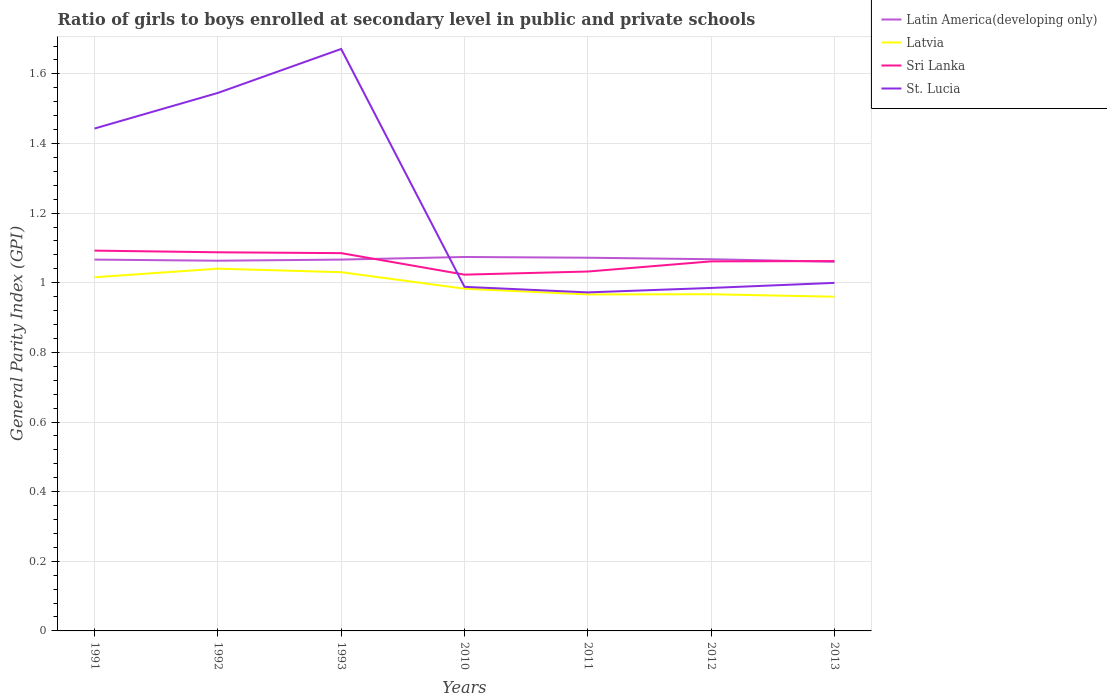Does the line corresponding to Latvia intersect with the line corresponding to St. Lucia?
Provide a short and direct response. No. Across all years, what is the maximum general parity index in Sri Lanka?
Provide a short and direct response. 1.02. In which year was the general parity index in Latvia maximum?
Provide a short and direct response. 2013. What is the total general parity index in Latvia in the graph?
Offer a terse response. 0.03. What is the difference between the highest and the second highest general parity index in Latvia?
Your response must be concise. 0.08. Is the general parity index in Latvia strictly greater than the general parity index in St. Lucia over the years?
Keep it short and to the point. Yes. How many years are there in the graph?
Offer a very short reply. 7. Are the values on the major ticks of Y-axis written in scientific E-notation?
Ensure brevity in your answer.  No. Does the graph contain any zero values?
Your response must be concise. No. Does the graph contain grids?
Ensure brevity in your answer.  Yes. How many legend labels are there?
Give a very brief answer. 4. How are the legend labels stacked?
Your answer should be compact. Vertical. What is the title of the graph?
Ensure brevity in your answer.  Ratio of girls to boys enrolled at secondary level in public and private schools. What is the label or title of the Y-axis?
Give a very brief answer. General Parity Index (GPI). What is the General Parity Index (GPI) of Latin America(developing only) in 1991?
Give a very brief answer. 1.07. What is the General Parity Index (GPI) in Latvia in 1991?
Your answer should be compact. 1.02. What is the General Parity Index (GPI) of Sri Lanka in 1991?
Your response must be concise. 1.09. What is the General Parity Index (GPI) of St. Lucia in 1991?
Your answer should be compact. 1.44. What is the General Parity Index (GPI) of Latin America(developing only) in 1992?
Make the answer very short. 1.06. What is the General Parity Index (GPI) of Latvia in 1992?
Provide a short and direct response. 1.04. What is the General Parity Index (GPI) of Sri Lanka in 1992?
Your response must be concise. 1.09. What is the General Parity Index (GPI) in St. Lucia in 1992?
Your response must be concise. 1.55. What is the General Parity Index (GPI) in Latin America(developing only) in 1993?
Offer a very short reply. 1.07. What is the General Parity Index (GPI) of Latvia in 1993?
Provide a succinct answer. 1.03. What is the General Parity Index (GPI) in Sri Lanka in 1993?
Give a very brief answer. 1.09. What is the General Parity Index (GPI) of St. Lucia in 1993?
Your answer should be compact. 1.67. What is the General Parity Index (GPI) of Latin America(developing only) in 2010?
Keep it short and to the point. 1.07. What is the General Parity Index (GPI) of Latvia in 2010?
Ensure brevity in your answer.  0.98. What is the General Parity Index (GPI) in Sri Lanka in 2010?
Your answer should be very brief. 1.02. What is the General Parity Index (GPI) in St. Lucia in 2010?
Make the answer very short. 0.99. What is the General Parity Index (GPI) of Latin America(developing only) in 2011?
Ensure brevity in your answer.  1.07. What is the General Parity Index (GPI) in Latvia in 2011?
Make the answer very short. 0.97. What is the General Parity Index (GPI) of Sri Lanka in 2011?
Make the answer very short. 1.03. What is the General Parity Index (GPI) in St. Lucia in 2011?
Provide a succinct answer. 0.97. What is the General Parity Index (GPI) in Latin America(developing only) in 2012?
Your answer should be compact. 1.07. What is the General Parity Index (GPI) in Latvia in 2012?
Provide a short and direct response. 0.97. What is the General Parity Index (GPI) in Sri Lanka in 2012?
Your answer should be very brief. 1.06. What is the General Parity Index (GPI) in St. Lucia in 2012?
Provide a short and direct response. 0.99. What is the General Parity Index (GPI) in Latin America(developing only) in 2013?
Offer a very short reply. 1.06. What is the General Parity Index (GPI) of Latvia in 2013?
Ensure brevity in your answer.  0.96. What is the General Parity Index (GPI) of Sri Lanka in 2013?
Ensure brevity in your answer.  1.06. What is the General Parity Index (GPI) in St. Lucia in 2013?
Make the answer very short. 1. Across all years, what is the maximum General Parity Index (GPI) of Latin America(developing only)?
Keep it short and to the point. 1.07. Across all years, what is the maximum General Parity Index (GPI) of Latvia?
Provide a short and direct response. 1.04. Across all years, what is the maximum General Parity Index (GPI) of Sri Lanka?
Make the answer very short. 1.09. Across all years, what is the maximum General Parity Index (GPI) of St. Lucia?
Make the answer very short. 1.67. Across all years, what is the minimum General Parity Index (GPI) of Latin America(developing only)?
Offer a very short reply. 1.06. Across all years, what is the minimum General Parity Index (GPI) of Latvia?
Ensure brevity in your answer.  0.96. Across all years, what is the minimum General Parity Index (GPI) of Sri Lanka?
Offer a terse response. 1.02. Across all years, what is the minimum General Parity Index (GPI) of St. Lucia?
Make the answer very short. 0.97. What is the total General Parity Index (GPI) in Latin America(developing only) in the graph?
Your response must be concise. 7.47. What is the total General Parity Index (GPI) of Latvia in the graph?
Offer a very short reply. 6.96. What is the total General Parity Index (GPI) in Sri Lanka in the graph?
Your answer should be very brief. 7.44. What is the total General Parity Index (GPI) of St. Lucia in the graph?
Offer a terse response. 8.61. What is the difference between the General Parity Index (GPI) in Latin America(developing only) in 1991 and that in 1992?
Keep it short and to the point. 0. What is the difference between the General Parity Index (GPI) in Latvia in 1991 and that in 1992?
Your answer should be very brief. -0.02. What is the difference between the General Parity Index (GPI) in Sri Lanka in 1991 and that in 1992?
Keep it short and to the point. 0. What is the difference between the General Parity Index (GPI) of St. Lucia in 1991 and that in 1992?
Provide a short and direct response. -0.1. What is the difference between the General Parity Index (GPI) in Latvia in 1991 and that in 1993?
Keep it short and to the point. -0.01. What is the difference between the General Parity Index (GPI) in Sri Lanka in 1991 and that in 1993?
Provide a short and direct response. 0.01. What is the difference between the General Parity Index (GPI) of St. Lucia in 1991 and that in 1993?
Provide a short and direct response. -0.23. What is the difference between the General Parity Index (GPI) in Latin America(developing only) in 1991 and that in 2010?
Your answer should be compact. -0.01. What is the difference between the General Parity Index (GPI) of Latvia in 1991 and that in 2010?
Your answer should be very brief. 0.03. What is the difference between the General Parity Index (GPI) of Sri Lanka in 1991 and that in 2010?
Offer a terse response. 0.07. What is the difference between the General Parity Index (GPI) in St. Lucia in 1991 and that in 2010?
Keep it short and to the point. 0.45. What is the difference between the General Parity Index (GPI) of Latin America(developing only) in 1991 and that in 2011?
Your answer should be compact. -0.01. What is the difference between the General Parity Index (GPI) of Latvia in 1991 and that in 2011?
Give a very brief answer. 0.05. What is the difference between the General Parity Index (GPI) in Sri Lanka in 1991 and that in 2011?
Offer a very short reply. 0.06. What is the difference between the General Parity Index (GPI) of St. Lucia in 1991 and that in 2011?
Provide a succinct answer. 0.47. What is the difference between the General Parity Index (GPI) in Latin America(developing only) in 1991 and that in 2012?
Offer a very short reply. -0. What is the difference between the General Parity Index (GPI) in Latvia in 1991 and that in 2012?
Your answer should be very brief. 0.05. What is the difference between the General Parity Index (GPI) in Sri Lanka in 1991 and that in 2012?
Give a very brief answer. 0.03. What is the difference between the General Parity Index (GPI) in St. Lucia in 1991 and that in 2012?
Provide a succinct answer. 0.46. What is the difference between the General Parity Index (GPI) in Latin America(developing only) in 1991 and that in 2013?
Ensure brevity in your answer.  0.01. What is the difference between the General Parity Index (GPI) in Latvia in 1991 and that in 2013?
Make the answer very short. 0.06. What is the difference between the General Parity Index (GPI) of St. Lucia in 1991 and that in 2013?
Your response must be concise. 0.44. What is the difference between the General Parity Index (GPI) in Latin America(developing only) in 1992 and that in 1993?
Give a very brief answer. -0. What is the difference between the General Parity Index (GPI) of Latvia in 1992 and that in 1993?
Keep it short and to the point. 0.01. What is the difference between the General Parity Index (GPI) in Sri Lanka in 1992 and that in 1993?
Keep it short and to the point. 0. What is the difference between the General Parity Index (GPI) of St. Lucia in 1992 and that in 1993?
Give a very brief answer. -0.13. What is the difference between the General Parity Index (GPI) in Latin America(developing only) in 1992 and that in 2010?
Make the answer very short. -0.01. What is the difference between the General Parity Index (GPI) of Latvia in 1992 and that in 2010?
Give a very brief answer. 0.06. What is the difference between the General Parity Index (GPI) of Sri Lanka in 1992 and that in 2010?
Offer a terse response. 0.06. What is the difference between the General Parity Index (GPI) of St. Lucia in 1992 and that in 2010?
Your answer should be compact. 0.56. What is the difference between the General Parity Index (GPI) in Latin America(developing only) in 1992 and that in 2011?
Your response must be concise. -0.01. What is the difference between the General Parity Index (GPI) in Latvia in 1992 and that in 2011?
Offer a terse response. 0.07. What is the difference between the General Parity Index (GPI) of Sri Lanka in 1992 and that in 2011?
Your response must be concise. 0.06. What is the difference between the General Parity Index (GPI) in St. Lucia in 1992 and that in 2011?
Your answer should be very brief. 0.57. What is the difference between the General Parity Index (GPI) of Latin America(developing only) in 1992 and that in 2012?
Offer a very short reply. -0. What is the difference between the General Parity Index (GPI) in Latvia in 1992 and that in 2012?
Keep it short and to the point. 0.07. What is the difference between the General Parity Index (GPI) in Sri Lanka in 1992 and that in 2012?
Make the answer very short. 0.03. What is the difference between the General Parity Index (GPI) in St. Lucia in 1992 and that in 2012?
Your response must be concise. 0.56. What is the difference between the General Parity Index (GPI) in Latin America(developing only) in 1992 and that in 2013?
Provide a succinct answer. 0. What is the difference between the General Parity Index (GPI) of Latvia in 1992 and that in 2013?
Keep it short and to the point. 0.08. What is the difference between the General Parity Index (GPI) in Sri Lanka in 1992 and that in 2013?
Give a very brief answer. 0.03. What is the difference between the General Parity Index (GPI) in St. Lucia in 1992 and that in 2013?
Make the answer very short. 0.55. What is the difference between the General Parity Index (GPI) of Latin America(developing only) in 1993 and that in 2010?
Keep it short and to the point. -0.01. What is the difference between the General Parity Index (GPI) of Latvia in 1993 and that in 2010?
Provide a short and direct response. 0.05. What is the difference between the General Parity Index (GPI) of Sri Lanka in 1993 and that in 2010?
Offer a very short reply. 0.06. What is the difference between the General Parity Index (GPI) of St. Lucia in 1993 and that in 2010?
Keep it short and to the point. 0.68. What is the difference between the General Parity Index (GPI) in Latin America(developing only) in 1993 and that in 2011?
Your answer should be very brief. -0.01. What is the difference between the General Parity Index (GPI) of Latvia in 1993 and that in 2011?
Give a very brief answer. 0.06. What is the difference between the General Parity Index (GPI) of Sri Lanka in 1993 and that in 2011?
Your response must be concise. 0.05. What is the difference between the General Parity Index (GPI) in St. Lucia in 1993 and that in 2011?
Make the answer very short. 0.7. What is the difference between the General Parity Index (GPI) in Latin America(developing only) in 1993 and that in 2012?
Provide a succinct answer. -0. What is the difference between the General Parity Index (GPI) of Latvia in 1993 and that in 2012?
Your response must be concise. 0.06. What is the difference between the General Parity Index (GPI) of Sri Lanka in 1993 and that in 2012?
Your response must be concise. 0.02. What is the difference between the General Parity Index (GPI) of St. Lucia in 1993 and that in 2012?
Your response must be concise. 0.69. What is the difference between the General Parity Index (GPI) of Latin America(developing only) in 1993 and that in 2013?
Offer a terse response. 0.01. What is the difference between the General Parity Index (GPI) of Latvia in 1993 and that in 2013?
Offer a terse response. 0.07. What is the difference between the General Parity Index (GPI) of Sri Lanka in 1993 and that in 2013?
Offer a very short reply. 0.02. What is the difference between the General Parity Index (GPI) of St. Lucia in 1993 and that in 2013?
Provide a succinct answer. 0.67. What is the difference between the General Parity Index (GPI) of Latin America(developing only) in 2010 and that in 2011?
Provide a succinct answer. 0. What is the difference between the General Parity Index (GPI) of Latvia in 2010 and that in 2011?
Make the answer very short. 0.02. What is the difference between the General Parity Index (GPI) in Sri Lanka in 2010 and that in 2011?
Ensure brevity in your answer.  -0.01. What is the difference between the General Parity Index (GPI) of St. Lucia in 2010 and that in 2011?
Your answer should be compact. 0.02. What is the difference between the General Parity Index (GPI) of Latin America(developing only) in 2010 and that in 2012?
Give a very brief answer. 0.01. What is the difference between the General Parity Index (GPI) of Latvia in 2010 and that in 2012?
Your answer should be compact. 0.02. What is the difference between the General Parity Index (GPI) of Sri Lanka in 2010 and that in 2012?
Offer a very short reply. -0.04. What is the difference between the General Parity Index (GPI) of St. Lucia in 2010 and that in 2012?
Ensure brevity in your answer.  0. What is the difference between the General Parity Index (GPI) in Latin America(developing only) in 2010 and that in 2013?
Your response must be concise. 0.01. What is the difference between the General Parity Index (GPI) in Latvia in 2010 and that in 2013?
Offer a terse response. 0.02. What is the difference between the General Parity Index (GPI) of Sri Lanka in 2010 and that in 2013?
Your answer should be very brief. -0.04. What is the difference between the General Parity Index (GPI) of St. Lucia in 2010 and that in 2013?
Make the answer very short. -0.01. What is the difference between the General Parity Index (GPI) of Latin America(developing only) in 2011 and that in 2012?
Offer a very short reply. 0. What is the difference between the General Parity Index (GPI) in Latvia in 2011 and that in 2012?
Make the answer very short. -0. What is the difference between the General Parity Index (GPI) in Sri Lanka in 2011 and that in 2012?
Ensure brevity in your answer.  -0.03. What is the difference between the General Parity Index (GPI) of St. Lucia in 2011 and that in 2012?
Ensure brevity in your answer.  -0.01. What is the difference between the General Parity Index (GPI) of Latin America(developing only) in 2011 and that in 2013?
Give a very brief answer. 0.01. What is the difference between the General Parity Index (GPI) in Latvia in 2011 and that in 2013?
Make the answer very short. 0.01. What is the difference between the General Parity Index (GPI) of Sri Lanka in 2011 and that in 2013?
Make the answer very short. -0.03. What is the difference between the General Parity Index (GPI) of St. Lucia in 2011 and that in 2013?
Offer a terse response. -0.03. What is the difference between the General Parity Index (GPI) in Latin America(developing only) in 2012 and that in 2013?
Offer a very short reply. 0.01. What is the difference between the General Parity Index (GPI) of Latvia in 2012 and that in 2013?
Provide a short and direct response. 0.01. What is the difference between the General Parity Index (GPI) of Sri Lanka in 2012 and that in 2013?
Ensure brevity in your answer.  -0. What is the difference between the General Parity Index (GPI) of St. Lucia in 2012 and that in 2013?
Ensure brevity in your answer.  -0.01. What is the difference between the General Parity Index (GPI) of Latin America(developing only) in 1991 and the General Parity Index (GPI) of Latvia in 1992?
Give a very brief answer. 0.03. What is the difference between the General Parity Index (GPI) in Latin America(developing only) in 1991 and the General Parity Index (GPI) in Sri Lanka in 1992?
Keep it short and to the point. -0.02. What is the difference between the General Parity Index (GPI) of Latin America(developing only) in 1991 and the General Parity Index (GPI) of St. Lucia in 1992?
Make the answer very short. -0.48. What is the difference between the General Parity Index (GPI) in Latvia in 1991 and the General Parity Index (GPI) in Sri Lanka in 1992?
Keep it short and to the point. -0.07. What is the difference between the General Parity Index (GPI) in Latvia in 1991 and the General Parity Index (GPI) in St. Lucia in 1992?
Ensure brevity in your answer.  -0.53. What is the difference between the General Parity Index (GPI) of Sri Lanka in 1991 and the General Parity Index (GPI) of St. Lucia in 1992?
Provide a short and direct response. -0.45. What is the difference between the General Parity Index (GPI) of Latin America(developing only) in 1991 and the General Parity Index (GPI) of Latvia in 1993?
Your answer should be very brief. 0.04. What is the difference between the General Parity Index (GPI) in Latin America(developing only) in 1991 and the General Parity Index (GPI) in Sri Lanka in 1993?
Provide a short and direct response. -0.02. What is the difference between the General Parity Index (GPI) in Latin America(developing only) in 1991 and the General Parity Index (GPI) in St. Lucia in 1993?
Your response must be concise. -0.6. What is the difference between the General Parity Index (GPI) of Latvia in 1991 and the General Parity Index (GPI) of Sri Lanka in 1993?
Your answer should be very brief. -0.07. What is the difference between the General Parity Index (GPI) in Latvia in 1991 and the General Parity Index (GPI) in St. Lucia in 1993?
Your answer should be very brief. -0.66. What is the difference between the General Parity Index (GPI) in Sri Lanka in 1991 and the General Parity Index (GPI) in St. Lucia in 1993?
Make the answer very short. -0.58. What is the difference between the General Parity Index (GPI) of Latin America(developing only) in 1991 and the General Parity Index (GPI) of Latvia in 2010?
Make the answer very short. 0.08. What is the difference between the General Parity Index (GPI) of Latin America(developing only) in 1991 and the General Parity Index (GPI) of Sri Lanka in 2010?
Your response must be concise. 0.04. What is the difference between the General Parity Index (GPI) of Latin America(developing only) in 1991 and the General Parity Index (GPI) of St. Lucia in 2010?
Your answer should be very brief. 0.08. What is the difference between the General Parity Index (GPI) of Latvia in 1991 and the General Parity Index (GPI) of Sri Lanka in 2010?
Offer a terse response. -0.01. What is the difference between the General Parity Index (GPI) of Latvia in 1991 and the General Parity Index (GPI) of St. Lucia in 2010?
Keep it short and to the point. 0.03. What is the difference between the General Parity Index (GPI) in Sri Lanka in 1991 and the General Parity Index (GPI) in St. Lucia in 2010?
Your answer should be very brief. 0.1. What is the difference between the General Parity Index (GPI) in Latin America(developing only) in 1991 and the General Parity Index (GPI) in Latvia in 2011?
Your answer should be compact. 0.1. What is the difference between the General Parity Index (GPI) of Latin America(developing only) in 1991 and the General Parity Index (GPI) of Sri Lanka in 2011?
Your answer should be very brief. 0.03. What is the difference between the General Parity Index (GPI) in Latin America(developing only) in 1991 and the General Parity Index (GPI) in St. Lucia in 2011?
Your answer should be very brief. 0.09. What is the difference between the General Parity Index (GPI) in Latvia in 1991 and the General Parity Index (GPI) in Sri Lanka in 2011?
Offer a very short reply. -0.02. What is the difference between the General Parity Index (GPI) in Latvia in 1991 and the General Parity Index (GPI) in St. Lucia in 2011?
Offer a terse response. 0.04. What is the difference between the General Parity Index (GPI) of Sri Lanka in 1991 and the General Parity Index (GPI) of St. Lucia in 2011?
Provide a succinct answer. 0.12. What is the difference between the General Parity Index (GPI) of Latin America(developing only) in 1991 and the General Parity Index (GPI) of Latvia in 2012?
Provide a succinct answer. 0.1. What is the difference between the General Parity Index (GPI) in Latin America(developing only) in 1991 and the General Parity Index (GPI) in Sri Lanka in 2012?
Provide a short and direct response. 0.01. What is the difference between the General Parity Index (GPI) in Latin America(developing only) in 1991 and the General Parity Index (GPI) in St. Lucia in 2012?
Your answer should be compact. 0.08. What is the difference between the General Parity Index (GPI) in Latvia in 1991 and the General Parity Index (GPI) in Sri Lanka in 2012?
Give a very brief answer. -0.05. What is the difference between the General Parity Index (GPI) of Latvia in 1991 and the General Parity Index (GPI) of St. Lucia in 2012?
Offer a terse response. 0.03. What is the difference between the General Parity Index (GPI) of Sri Lanka in 1991 and the General Parity Index (GPI) of St. Lucia in 2012?
Give a very brief answer. 0.11. What is the difference between the General Parity Index (GPI) of Latin America(developing only) in 1991 and the General Parity Index (GPI) of Latvia in 2013?
Offer a very short reply. 0.11. What is the difference between the General Parity Index (GPI) in Latin America(developing only) in 1991 and the General Parity Index (GPI) in Sri Lanka in 2013?
Offer a very short reply. 0. What is the difference between the General Parity Index (GPI) in Latin America(developing only) in 1991 and the General Parity Index (GPI) in St. Lucia in 2013?
Your answer should be compact. 0.07. What is the difference between the General Parity Index (GPI) in Latvia in 1991 and the General Parity Index (GPI) in Sri Lanka in 2013?
Give a very brief answer. -0.05. What is the difference between the General Parity Index (GPI) of Latvia in 1991 and the General Parity Index (GPI) of St. Lucia in 2013?
Your response must be concise. 0.02. What is the difference between the General Parity Index (GPI) of Sri Lanka in 1991 and the General Parity Index (GPI) of St. Lucia in 2013?
Ensure brevity in your answer.  0.09. What is the difference between the General Parity Index (GPI) of Latin America(developing only) in 1992 and the General Parity Index (GPI) of Latvia in 1993?
Ensure brevity in your answer.  0.03. What is the difference between the General Parity Index (GPI) in Latin America(developing only) in 1992 and the General Parity Index (GPI) in Sri Lanka in 1993?
Keep it short and to the point. -0.02. What is the difference between the General Parity Index (GPI) of Latin America(developing only) in 1992 and the General Parity Index (GPI) of St. Lucia in 1993?
Offer a terse response. -0.61. What is the difference between the General Parity Index (GPI) of Latvia in 1992 and the General Parity Index (GPI) of Sri Lanka in 1993?
Make the answer very short. -0.04. What is the difference between the General Parity Index (GPI) of Latvia in 1992 and the General Parity Index (GPI) of St. Lucia in 1993?
Your response must be concise. -0.63. What is the difference between the General Parity Index (GPI) of Sri Lanka in 1992 and the General Parity Index (GPI) of St. Lucia in 1993?
Provide a short and direct response. -0.58. What is the difference between the General Parity Index (GPI) of Latin America(developing only) in 1992 and the General Parity Index (GPI) of Latvia in 2010?
Your answer should be compact. 0.08. What is the difference between the General Parity Index (GPI) in Latin America(developing only) in 1992 and the General Parity Index (GPI) in Sri Lanka in 2010?
Make the answer very short. 0.04. What is the difference between the General Parity Index (GPI) of Latin America(developing only) in 1992 and the General Parity Index (GPI) of St. Lucia in 2010?
Provide a succinct answer. 0.07. What is the difference between the General Parity Index (GPI) in Latvia in 1992 and the General Parity Index (GPI) in Sri Lanka in 2010?
Provide a short and direct response. 0.02. What is the difference between the General Parity Index (GPI) of Latvia in 1992 and the General Parity Index (GPI) of St. Lucia in 2010?
Give a very brief answer. 0.05. What is the difference between the General Parity Index (GPI) in Sri Lanka in 1992 and the General Parity Index (GPI) in St. Lucia in 2010?
Give a very brief answer. 0.1. What is the difference between the General Parity Index (GPI) in Latin America(developing only) in 1992 and the General Parity Index (GPI) in Latvia in 2011?
Keep it short and to the point. 0.1. What is the difference between the General Parity Index (GPI) in Latin America(developing only) in 1992 and the General Parity Index (GPI) in Sri Lanka in 2011?
Your answer should be very brief. 0.03. What is the difference between the General Parity Index (GPI) of Latin America(developing only) in 1992 and the General Parity Index (GPI) of St. Lucia in 2011?
Offer a terse response. 0.09. What is the difference between the General Parity Index (GPI) in Latvia in 1992 and the General Parity Index (GPI) in Sri Lanka in 2011?
Provide a short and direct response. 0.01. What is the difference between the General Parity Index (GPI) of Latvia in 1992 and the General Parity Index (GPI) of St. Lucia in 2011?
Ensure brevity in your answer.  0.07. What is the difference between the General Parity Index (GPI) in Sri Lanka in 1992 and the General Parity Index (GPI) in St. Lucia in 2011?
Provide a short and direct response. 0.12. What is the difference between the General Parity Index (GPI) of Latin America(developing only) in 1992 and the General Parity Index (GPI) of Latvia in 2012?
Your answer should be very brief. 0.1. What is the difference between the General Parity Index (GPI) of Latin America(developing only) in 1992 and the General Parity Index (GPI) of Sri Lanka in 2012?
Your answer should be very brief. 0. What is the difference between the General Parity Index (GPI) of Latin America(developing only) in 1992 and the General Parity Index (GPI) of St. Lucia in 2012?
Your answer should be compact. 0.08. What is the difference between the General Parity Index (GPI) of Latvia in 1992 and the General Parity Index (GPI) of Sri Lanka in 2012?
Give a very brief answer. -0.02. What is the difference between the General Parity Index (GPI) in Latvia in 1992 and the General Parity Index (GPI) in St. Lucia in 2012?
Offer a very short reply. 0.06. What is the difference between the General Parity Index (GPI) of Sri Lanka in 1992 and the General Parity Index (GPI) of St. Lucia in 2012?
Provide a succinct answer. 0.1. What is the difference between the General Parity Index (GPI) in Latin America(developing only) in 1992 and the General Parity Index (GPI) in Latvia in 2013?
Offer a very short reply. 0.1. What is the difference between the General Parity Index (GPI) of Latin America(developing only) in 1992 and the General Parity Index (GPI) of St. Lucia in 2013?
Your answer should be compact. 0.06. What is the difference between the General Parity Index (GPI) in Latvia in 1992 and the General Parity Index (GPI) in Sri Lanka in 2013?
Make the answer very short. -0.02. What is the difference between the General Parity Index (GPI) in Latvia in 1992 and the General Parity Index (GPI) in St. Lucia in 2013?
Make the answer very short. 0.04. What is the difference between the General Parity Index (GPI) in Sri Lanka in 1992 and the General Parity Index (GPI) in St. Lucia in 2013?
Your answer should be compact. 0.09. What is the difference between the General Parity Index (GPI) in Latin America(developing only) in 1993 and the General Parity Index (GPI) in Latvia in 2010?
Your response must be concise. 0.08. What is the difference between the General Parity Index (GPI) of Latin America(developing only) in 1993 and the General Parity Index (GPI) of Sri Lanka in 2010?
Provide a short and direct response. 0.04. What is the difference between the General Parity Index (GPI) in Latin America(developing only) in 1993 and the General Parity Index (GPI) in St. Lucia in 2010?
Your response must be concise. 0.08. What is the difference between the General Parity Index (GPI) in Latvia in 1993 and the General Parity Index (GPI) in Sri Lanka in 2010?
Make the answer very short. 0.01. What is the difference between the General Parity Index (GPI) in Latvia in 1993 and the General Parity Index (GPI) in St. Lucia in 2010?
Keep it short and to the point. 0.04. What is the difference between the General Parity Index (GPI) of Sri Lanka in 1993 and the General Parity Index (GPI) of St. Lucia in 2010?
Provide a succinct answer. 0.1. What is the difference between the General Parity Index (GPI) in Latin America(developing only) in 1993 and the General Parity Index (GPI) in Latvia in 2011?
Your response must be concise. 0.1. What is the difference between the General Parity Index (GPI) of Latin America(developing only) in 1993 and the General Parity Index (GPI) of Sri Lanka in 2011?
Make the answer very short. 0.03. What is the difference between the General Parity Index (GPI) in Latin America(developing only) in 1993 and the General Parity Index (GPI) in St. Lucia in 2011?
Provide a short and direct response. 0.09. What is the difference between the General Parity Index (GPI) of Latvia in 1993 and the General Parity Index (GPI) of Sri Lanka in 2011?
Provide a short and direct response. -0. What is the difference between the General Parity Index (GPI) in Latvia in 1993 and the General Parity Index (GPI) in St. Lucia in 2011?
Your answer should be compact. 0.06. What is the difference between the General Parity Index (GPI) in Sri Lanka in 1993 and the General Parity Index (GPI) in St. Lucia in 2011?
Make the answer very short. 0.11. What is the difference between the General Parity Index (GPI) of Latin America(developing only) in 1993 and the General Parity Index (GPI) of Latvia in 2012?
Provide a short and direct response. 0.1. What is the difference between the General Parity Index (GPI) of Latin America(developing only) in 1993 and the General Parity Index (GPI) of Sri Lanka in 2012?
Ensure brevity in your answer.  0.01. What is the difference between the General Parity Index (GPI) of Latin America(developing only) in 1993 and the General Parity Index (GPI) of St. Lucia in 2012?
Keep it short and to the point. 0.08. What is the difference between the General Parity Index (GPI) of Latvia in 1993 and the General Parity Index (GPI) of Sri Lanka in 2012?
Provide a succinct answer. -0.03. What is the difference between the General Parity Index (GPI) in Latvia in 1993 and the General Parity Index (GPI) in St. Lucia in 2012?
Keep it short and to the point. 0.05. What is the difference between the General Parity Index (GPI) of Sri Lanka in 1993 and the General Parity Index (GPI) of St. Lucia in 2012?
Provide a short and direct response. 0.1. What is the difference between the General Parity Index (GPI) in Latin America(developing only) in 1993 and the General Parity Index (GPI) in Latvia in 2013?
Your answer should be compact. 0.11. What is the difference between the General Parity Index (GPI) in Latin America(developing only) in 1993 and the General Parity Index (GPI) in Sri Lanka in 2013?
Keep it short and to the point. 0. What is the difference between the General Parity Index (GPI) in Latin America(developing only) in 1993 and the General Parity Index (GPI) in St. Lucia in 2013?
Ensure brevity in your answer.  0.07. What is the difference between the General Parity Index (GPI) in Latvia in 1993 and the General Parity Index (GPI) in Sri Lanka in 2013?
Keep it short and to the point. -0.03. What is the difference between the General Parity Index (GPI) of Latvia in 1993 and the General Parity Index (GPI) of St. Lucia in 2013?
Offer a very short reply. 0.03. What is the difference between the General Parity Index (GPI) of Sri Lanka in 1993 and the General Parity Index (GPI) of St. Lucia in 2013?
Make the answer very short. 0.09. What is the difference between the General Parity Index (GPI) in Latin America(developing only) in 2010 and the General Parity Index (GPI) in Latvia in 2011?
Make the answer very short. 0.11. What is the difference between the General Parity Index (GPI) in Latin America(developing only) in 2010 and the General Parity Index (GPI) in Sri Lanka in 2011?
Provide a succinct answer. 0.04. What is the difference between the General Parity Index (GPI) of Latin America(developing only) in 2010 and the General Parity Index (GPI) of St. Lucia in 2011?
Your response must be concise. 0.1. What is the difference between the General Parity Index (GPI) of Latvia in 2010 and the General Parity Index (GPI) of Sri Lanka in 2011?
Give a very brief answer. -0.05. What is the difference between the General Parity Index (GPI) in Latvia in 2010 and the General Parity Index (GPI) in St. Lucia in 2011?
Your response must be concise. 0.01. What is the difference between the General Parity Index (GPI) in Sri Lanka in 2010 and the General Parity Index (GPI) in St. Lucia in 2011?
Make the answer very short. 0.05. What is the difference between the General Parity Index (GPI) in Latin America(developing only) in 2010 and the General Parity Index (GPI) in Latvia in 2012?
Offer a very short reply. 0.11. What is the difference between the General Parity Index (GPI) in Latin America(developing only) in 2010 and the General Parity Index (GPI) in Sri Lanka in 2012?
Provide a succinct answer. 0.01. What is the difference between the General Parity Index (GPI) in Latin America(developing only) in 2010 and the General Parity Index (GPI) in St. Lucia in 2012?
Offer a very short reply. 0.09. What is the difference between the General Parity Index (GPI) in Latvia in 2010 and the General Parity Index (GPI) in Sri Lanka in 2012?
Provide a succinct answer. -0.08. What is the difference between the General Parity Index (GPI) in Latvia in 2010 and the General Parity Index (GPI) in St. Lucia in 2012?
Provide a short and direct response. -0. What is the difference between the General Parity Index (GPI) in Sri Lanka in 2010 and the General Parity Index (GPI) in St. Lucia in 2012?
Your answer should be compact. 0.04. What is the difference between the General Parity Index (GPI) in Latin America(developing only) in 2010 and the General Parity Index (GPI) in Latvia in 2013?
Provide a succinct answer. 0.11. What is the difference between the General Parity Index (GPI) of Latin America(developing only) in 2010 and the General Parity Index (GPI) of Sri Lanka in 2013?
Offer a very short reply. 0.01. What is the difference between the General Parity Index (GPI) of Latin America(developing only) in 2010 and the General Parity Index (GPI) of St. Lucia in 2013?
Your answer should be very brief. 0.07. What is the difference between the General Parity Index (GPI) of Latvia in 2010 and the General Parity Index (GPI) of Sri Lanka in 2013?
Give a very brief answer. -0.08. What is the difference between the General Parity Index (GPI) of Latvia in 2010 and the General Parity Index (GPI) of St. Lucia in 2013?
Make the answer very short. -0.02. What is the difference between the General Parity Index (GPI) of Sri Lanka in 2010 and the General Parity Index (GPI) of St. Lucia in 2013?
Provide a short and direct response. 0.02. What is the difference between the General Parity Index (GPI) of Latin America(developing only) in 2011 and the General Parity Index (GPI) of Latvia in 2012?
Your answer should be very brief. 0.1. What is the difference between the General Parity Index (GPI) in Latin America(developing only) in 2011 and the General Parity Index (GPI) in Sri Lanka in 2012?
Offer a very short reply. 0.01. What is the difference between the General Parity Index (GPI) of Latin America(developing only) in 2011 and the General Parity Index (GPI) of St. Lucia in 2012?
Your answer should be very brief. 0.09. What is the difference between the General Parity Index (GPI) of Latvia in 2011 and the General Parity Index (GPI) of Sri Lanka in 2012?
Keep it short and to the point. -0.09. What is the difference between the General Parity Index (GPI) in Latvia in 2011 and the General Parity Index (GPI) in St. Lucia in 2012?
Make the answer very short. -0.02. What is the difference between the General Parity Index (GPI) of Sri Lanka in 2011 and the General Parity Index (GPI) of St. Lucia in 2012?
Give a very brief answer. 0.05. What is the difference between the General Parity Index (GPI) of Latin America(developing only) in 2011 and the General Parity Index (GPI) of Latvia in 2013?
Offer a very short reply. 0.11. What is the difference between the General Parity Index (GPI) of Latin America(developing only) in 2011 and the General Parity Index (GPI) of Sri Lanka in 2013?
Make the answer very short. 0.01. What is the difference between the General Parity Index (GPI) in Latin America(developing only) in 2011 and the General Parity Index (GPI) in St. Lucia in 2013?
Offer a terse response. 0.07. What is the difference between the General Parity Index (GPI) of Latvia in 2011 and the General Parity Index (GPI) of Sri Lanka in 2013?
Provide a succinct answer. -0.1. What is the difference between the General Parity Index (GPI) of Latvia in 2011 and the General Parity Index (GPI) of St. Lucia in 2013?
Offer a terse response. -0.03. What is the difference between the General Parity Index (GPI) in Sri Lanka in 2011 and the General Parity Index (GPI) in St. Lucia in 2013?
Provide a succinct answer. 0.03. What is the difference between the General Parity Index (GPI) in Latin America(developing only) in 2012 and the General Parity Index (GPI) in Latvia in 2013?
Your answer should be compact. 0.11. What is the difference between the General Parity Index (GPI) of Latin America(developing only) in 2012 and the General Parity Index (GPI) of Sri Lanka in 2013?
Your response must be concise. 0.01. What is the difference between the General Parity Index (GPI) of Latin America(developing only) in 2012 and the General Parity Index (GPI) of St. Lucia in 2013?
Ensure brevity in your answer.  0.07. What is the difference between the General Parity Index (GPI) of Latvia in 2012 and the General Parity Index (GPI) of Sri Lanka in 2013?
Ensure brevity in your answer.  -0.1. What is the difference between the General Parity Index (GPI) of Latvia in 2012 and the General Parity Index (GPI) of St. Lucia in 2013?
Make the answer very short. -0.03. What is the difference between the General Parity Index (GPI) in Sri Lanka in 2012 and the General Parity Index (GPI) in St. Lucia in 2013?
Give a very brief answer. 0.06. What is the average General Parity Index (GPI) of Latin America(developing only) per year?
Provide a short and direct response. 1.07. What is the average General Parity Index (GPI) in Sri Lanka per year?
Ensure brevity in your answer.  1.06. What is the average General Parity Index (GPI) of St. Lucia per year?
Keep it short and to the point. 1.23. In the year 1991, what is the difference between the General Parity Index (GPI) in Latin America(developing only) and General Parity Index (GPI) in Latvia?
Your answer should be compact. 0.05. In the year 1991, what is the difference between the General Parity Index (GPI) in Latin America(developing only) and General Parity Index (GPI) in Sri Lanka?
Keep it short and to the point. -0.03. In the year 1991, what is the difference between the General Parity Index (GPI) of Latin America(developing only) and General Parity Index (GPI) of St. Lucia?
Offer a very short reply. -0.38. In the year 1991, what is the difference between the General Parity Index (GPI) in Latvia and General Parity Index (GPI) in Sri Lanka?
Keep it short and to the point. -0.08. In the year 1991, what is the difference between the General Parity Index (GPI) in Latvia and General Parity Index (GPI) in St. Lucia?
Your answer should be compact. -0.43. In the year 1991, what is the difference between the General Parity Index (GPI) in Sri Lanka and General Parity Index (GPI) in St. Lucia?
Make the answer very short. -0.35. In the year 1992, what is the difference between the General Parity Index (GPI) of Latin America(developing only) and General Parity Index (GPI) of Latvia?
Give a very brief answer. 0.02. In the year 1992, what is the difference between the General Parity Index (GPI) in Latin America(developing only) and General Parity Index (GPI) in Sri Lanka?
Ensure brevity in your answer.  -0.02. In the year 1992, what is the difference between the General Parity Index (GPI) in Latin America(developing only) and General Parity Index (GPI) in St. Lucia?
Your answer should be very brief. -0.48. In the year 1992, what is the difference between the General Parity Index (GPI) of Latvia and General Parity Index (GPI) of Sri Lanka?
Offer a terse response. -0.05. In the year 1992, what is the difference between the General Parity Index (GPI) of Latvia and General Parity Index (GPI) of St. Lucia?
Provide a succinct answer. -0.5. In the year 1992, what is the difference between the General Parity Index (GPI) of Sri Lanka and General Parity Index (GPI) of St. Lucia?
Give a very brief answer. -0.46. In the year 1993, what is the difference between the General Parity Index (GPI) of Latin America(developing only) and General Parity Index (GPI) of Latvia?
Give a very brief answer. 0.04. In the year 1993, what is the difference between the General Parity Index (GPI) of Latin America(developing only) and General Parity Index (GPI) of Sri Lanka?
Provide a succinct answer. -0.02. In the year 1993, what is the difference between the General Parity Index (GPI) of Latin America(developing only) and General Parity Index (GPI) of St. Lucia?
Your response must be concise. -0.6. In the year 1993, what is the difference between the General Parity Index (GPI) of Latvia and General Parity Index (GPI) of Sri Lanka?
Ensure brevity in your answer.  -0.05. In the year 1993, what is the difference between the General Parity Index (GPI) in Latvia and General Parity Index (GPI) in St. Lucia?
Give a very brief answer. -0.64. In the year 1993, what is the difference between the General Parity Index (GPI) in Sri Lanka and General Parity Index (GPI) in St. Lucia?
Your answer should be very brief. -0.59. In the year 2010, what is the difference between the General Parity Index (GPI) in Latin America(developing only) and General Parity Index (GPI) in Latvia?
Keep it short and to the point. 0.09. In the year 2010, what is the difference between the General Parity Index (GPI) of Latin America(developing only) and General Parity Index (GPI) of Sri Lanka?
Make the answer very short. 0.05. In the year 2010, what is the difference between the General Parity Index (GPI) of Latin America(developing only) and General Parity Index (GPI) of St. Lucia?
Your answer should be very brief. 0.09. In the year 2010, what is the difference between the General Parity Index (GPI) of Latvia and General Parity Index (GPI) of Sri Lanka?
Keep it short and to the point. -0.04. In the year 2010, what is the difference between the General Parity Index (GPI) in Latvia and General Parity Index (GPI) in St. Lucia?
Your answer should be compact. -0.01. In the year 2010, what is the difference between the General Parity Index (GPI) in Sri Lanka and General Parity Index (GPI) in St. Lucia?
Your answer should be compact. 0.04. In the year 2011, what is the difference between the General Parity Index (GPI) of Latin America(developing only) and General Parity Index (GPI) of Latvia?
Provide a short and direct response. 0.11. In the year 2011, what is the difference between the General Parity Index (GPI) in Latin America(developing only) and General Parity Index (GPI) in Sri Lanka?
Make the answer very short. 0.04. In the year 2011, what is the difference between the General Parity Index (GPI) of Latin America(developing only) and General Parity Index (GPI) of St. Lucia?
Your answer should be compact. 0.1. In the year 2011, what is the difference between the General Parity Index (GPI) of Latvia and General Parity Index (GPI) of Sri Lanka?
Ensure brevity in your answer.  -0.07. In the year 2011, what is the difference between the General Parity Index (GPI) of Latvia and General Parity Index (GPI) of St. Lucia?
Ensure brevity in your answer.  -0.01. In the year 2011, what is the difference between the General Parity Index (GPI) of Sri Lanka and General Parity Index (GPI) of St. Lucia?
Provide a short and direct response. 0.06. In the year 2012, what is the difference between the General Parity Index (GPI) in Latin America(developing only) and General Parity Index (GPI) in Latvia?
Ensure brevity in your answer.  0.1. In the year 2012, what is the difference between the General Parity Index (GPI) in Latin America(developing only) and General Parity Index (GPI) in Sri Lanka?
Offer a very short reply. 0.01. In the year 2012, what is the difference between the General Parity Index (GPI) of Latin America(developing only) and General Parity Index (GPI) of St. Lucia?
Your response must be concise. 0.08. In the year 2012, what is the difference between the General Parity Index (GPI) of Latvia and General Parity Index (GPI) of Sri Lanka?
Your answer should be compact. -0.09. In the year 2012, what is the difference between the General Parity Index (GPI) in Latvia and General Parity Index (GPI) in St. Lucia?
Provide a short and direct response. -0.02. In the year 2012, what is the difference between the General Parity Index (GPI) of Sri Lanka and General Parity Index (GPI) of St. Lucia?
Keep it short and to the point. 0.08. In the year 2013, what is the difference between the General Parity Index (GPI) in Latin America(developing only) and General Parity Index (GPI) in Latvia?
Make the answer very short. 0.1. In the year 2013, what is the difference between the General Parity Index (GPI) in Latin America(developing only) and General Parity Index (GPI) in Sri Lanka?
Provide a short and direct response. -0. In the year 2013, what is the difference between the General Parity Index (GPI) in Latin America(developing only) and General Parity Index (GPI) in St. Lucia?
Make the answer very short. 0.06. In the year 2013, what is the difference between the General Parity Index (GPI) of Latvia and General Parity Index (GPI) of Sri Lanka?
Make the answer very short. -0.1. In the year 2013, what is the difference between the General Parity Index (GPI) in Latvia and General Parity Index (GPI) in St. Lucia?
Offer a terse response. -0.04. In the year 2013, what is the difference between the General Parity Index (GPI) of Sri Lanka and General Parity Index (GPI) of St. Lucia?
Your response must be concise. 0.06. What is the ratio of the General Parity Index (GPI) of Latin America(developing only) in 1991 to that in 1992?
Offer a terse response. 1. What is the ratio of the General Parity Index (GPI) of Latvia in 1991 to that in 1992?
Make the answer very short. 0.98. What is the ratio of the General Parity Index (GPI) of Sri Lanka in 1991 to that in 1992?
Keep it short and to the point. 1. What is the ratio of the General Parity Index (GPI) of St. Lucia in 1991 to that in 1992?
Offer a terse response. 0.93. What is the ratio of the General Parity Index (GPI) in Latvia in 1991 to that in 1993?
Provide a succinct answer. 0.99. What is the ratio of the General Parity Index (GPI) in Sri Lanka in 1991 to that in 1993?
Ensure brevity in your answer.  1.01. What is the ratio of the General Parity Index (GPI) in St. Lucia in 1991 to that in 1993?
Provide a succinct answer. 0.86. What is the ratio of the General Parity Index (GPI) in Latvia in 1991 to that in 2010?
Your response must be concise. 1.03. What is the ratio of the General Parity Index (GPI) in Sri Lanka in 1991 to that in 2010?
Provide a succinct answer. 1.07. What is the ratio of the General Parity Index (GPI) in St. Lucia in 1991 to that in 2010?
Make the answer very short. 1.46. What is the ratio of the General Parity Index (GPI) of Latin America(developing only) in 1991 to that in 2011?
Your answer should be compact. 0.99. What is the ratio of the General Parity Index (GPI) of Latvia in 1991 to that in 2011?
Provide a succinct answer. 1.05. What is the ratio of the General Parity Index (GPI) of Sri Lanka in 1991 to that in 2011?
Ensure brevity in your answer.  1.06. What is the ratio of the General Parity Index (GPI) in St. Lucia in 1991 to that in 2011?
Your answer should be compact. 1.48. What is the ratio of the General Parity Index (GPI) of Latvia in 1991 to that in 2012?
Your response must be concise. 1.05. What is the ratio of the General Parity Index (GPI) of Sri Lanka in 1991 to that in 2012?
Offer a very short reply. 1.03. What is the ratio of the General Parity Index (GPI) in St. Lucia in 1991 to that in 2012?
Your answer should be very brief. 1.46. What is the ratio of the General Parity Index (GPI) in Latin America(developing only) in 1991 to that in 2013?
Your answer should be very brief. 1.01. What is the ratio of the General Parity Index (GPI) of Latvia in 1991 to that in 2013?
Offer a very short reply. 1.06. What is the ratio of the General Parity Index (GPI) of Sri Lanka in 1991 to that in 2013?
Offer a terse response. 1.03. What is the ratio of the General Parity Index (GPI) of St. Lucia in 1991 to that in 2013?
Offer a terse response. 1.44. What is the ratio of the General Parity Index (GPI) of Latvia in 1992 to that in 1993?
Make the answer very short. 1.01. What is the ratio of the General Parity Index (GPI) of Sri Lanka in 1992 to that in 1993?
Your answer should be compact. 1. What is the ratio of the General Parity Index (GPI) of St. Lucia in 1992 to that in 1993?
Provide a short and direct response. 0.92. What is the ratio of the General Parity Index (GPI) in Latin America(developing only) in 1992 to that in 2010?
Provide a succinct answer. 0.99. What is the ratio of the General Parity Index (GPI) of Latvia in 1992 to that in 2010?
Keep it short and to the point. 1.06. What is the ratio of the General Parity Index (GPI) of Sri Lanka in 1992 to that in 2010?
Your response must be concise. 1.06. What is the ratio of the General Parity Index (GPI) of St. Lucia in 1992 to that in 2010?
Your answer should be very brief. 1.56. What is the ratio of the General Parity Index (GPI) in Latvia in 1992 to that in 2011?
Offer a terse response. 1.08. What is the ratio of the General Parity Index (GPI) of Sri Lanka in 1992 to that in 2011?
Your response must be concise. 1.05. What is the ratio of the General Parity Index (GPI) in St. Lucia in 1992 to that in 2011?
Make the answer very short. 1.59. What is the ratio of the General Parity Index (GPI) in Latin America(developing only) in 1992 to that in 2012?
Provide a succinct answer. 1. What is the ratio of the General Parity Index (GPI) of Latvia in 1992 to that in 2012?
Your response must be concise. 1.08. What is the ratio of the General Parity Index (GPI) of Sri Lanka in 1992 to that in 2012?
Your answer should be very brief. 1.02. What is the ratio of the General Parity Index (GPI) of St. Lucia in 1992 to that in 2012?
Make the answer very short. 1.57. What is the ratio of the General Parity Index (GPI) of Latin America(developing only) in 1992 to that in 2013?
Your answer should be very brief. 1. What is the ratio of the General Parity Index (GPI) in Latvia in 1992 to that in 2013?
Make the answer very short. 1.08. What is the ratio of the General Parity Index (GPI) of Sri Lanka in 1992 to that in 2013?
Keep it short and to the point. 1.02. What is the ratio of the General Parity Index (GPI) of St. Lucia in 1992 to that in 2013?
Offer a terse response. 1.55. What is the ratio of the General Parity Index (GPI) of Latin America(developing only) in 1993 to that in 2010?
Give a very brief answer. 0.99. What is the ratio of the General Parity Index (GPI) in Latvia in 1993 to that in 2010?
Your response must be concise. 1.05. What is the ratio of the General Parity Index (GPI) in Sri Lanka in 1993 to that in 2010?
Your answer should be very brief. 1.06. What is the ratio of the General Parity Index (GPI) of St. Lucia in 1993 to that in 2010?
Offer a terse response. 1.69. What is the ratio of the General Parity Index (GPI) of Latvia in 1993 to that in 2011?
Keep it short and to the point. 1.07. What is the ratio of the General Parity Index (GPI) of Sri Lanka in 1993 to that in 2011?
Your answer should be very brief. 1.05. What is the ratio of the General Parity Index (GPI) in St. Lucia in 1993 to that in 2011?
Your answer should be very brief. 1.72. What is the ratio of the General Parity Index (GPI) in Latin America(developing only) in 1993 to that in 2012?
Offer a terse response. 1. What is the ratio of the General Parity Index (GPI) in Latvia in 1993 to that in 2012?
Provide a short and direct response. 1.07. What is the ratio of the General Parity Index (GPI) in Sri Lanka in 1993 to that in 2012?
Offer a very short reply. 1.02. What is the ratio of the General Parity Index (GPI) of St. Lucia in 1993 to that in 2012?
Keep it short and to the point. 1.7. What is the ratio of the General Parity Index (GPI) in Latin America(developing only) in 1993 to that in 2013?
Keep it short and to the point. 1.01. What is the ratio of the General Parity Index (GPI) of Latvia in 1993 to that in 2013?
Your response must be concise. 1.07. What is the ratio of the General Parity Index (GPI) of Sri Lanka in 1993 to that in 2013?
Keep it short and to the point. 1.02. What is the ratio of the General Parity Index (GPI) of St. Lucia in 1993 to that in 2013?
Your answer should be very brief. 1.67. What is the ratio of the General Parity Index (GPI) in Latin America(developing only) in 2010 to that in 2011?
Provide a succinct answer. 1. What is the ratio of the General Parity Index (GPI) in Latvia in 2010 to that in 2011?
Your response must be concise. 1.02. What is the ratio of the General Parity Index (GPI) in St. Lucia in 2010 to that in 2011?
Provide a succinct answer. 1.02. What is the ratio of the General Parity Index (GPI) of Latvia in 2010 to that in 2012?
Provide a succinct answer. 1.02. What is the ratio of the General Parity Index (GPI) of Sri Lanka in 2010 to that in 2012?
Give a very brief answer. 0.96. What is the ratio of the General Parity Index (GPI) of St. Lucia in 2010 to that in 2012?
Your answer should be very brief. 1. What is the ratio of the General Parity Index (GPI) of Latin America(developing only) in 2010 to that in 2013?
Provide a succinct answer. 1.01. What is the ratio of the General Parity Index (GPI) of Sri Lanka in 2010 to that in 2013?
Provide a short and direct response. 0.96. What is the ratio of the General Parity Index (GPI) in St. Lucia in 2010 to that in 2013?
Your answer should be compact. 0.99. What is the ratio of the General Parity Index (GPI) in Latin America(developing only) in 2011 to that in 2012?
Offer a very short reply. 1. What is the ratio of the General Parity Index (GPI) in Sri Lanka in 2011 to that in 2012?
Offer a very short reply. 0.97. What is the ratio of the General Parity Index (GPI) in Latin America(developing only) in 2011 to that in 2013?
Make the answer very short. 1.01. What is the ratio of the General Parity Index (GPI) of Latvia in 2011 to that in 2013?
Provide a short and direct response. 1.01. What is the ratio of the General Parity Index (GPI) in Sri Lanka in 2011 to that in 2013?
Ensure brevity in your answer.  0.97. What is the ratio of the General Parity Index (GPI) of St. Lucia in 2011 to that in 2013?
Offer a terse response. 0.97. What is the ratio of the General Parity Index (GPI) of Latin America(developing only) in 2012 to that in 2013?
Your answer should be compact. 1.01. What is the ratio of the General Parity Index (GPI) in Latvia in 2012 to that in 2013?
Offer a very short reply. 1.01. What is the ratio of the General Parity Index (GPI) of Sri Lanka in 2012 to that in 2013?
Offer a terse response. 1. What is the ratio of the General Parity Index (GPI) in St. Lucia in 2012 to that in 2013?
Your answer should be very brief. 0.99. What is the difference between the highest and the second highest General Parity Index (GPI) of Latin America(developing only)?
Your response must be concise. 0. What is the difference between the highest and the second highest General Parity Index (GPI) in Latvia?
Keep it short and to the point. 0.01. What is the difference between the highest and the second highest General Parity Index (GPI) of Sri Lanka?
Make the answer very short. 0. What is the difference between the highest and the second highest General Parity Index (GPI) in St. Lucia?
Offer a terse response. 0.13. What is the difference between the highest and the lowest General Parity Index (GPI) of Latin America(developing only)?
Offer a very short reply. 0.01. What is the difference between the highest and the lowest General Parity Index (GPI) in Latvia?
Keep it short and to the point. 0.08. What is the difference between the highest and the lowest General Parity Index (GPI) in Sri Lanka?
Provide a succinct answer. 0.07. What is the difference between the highest and the lowest General Parity Index (GPI) in St. Lucia?
Make the answer very short. 0.7. 